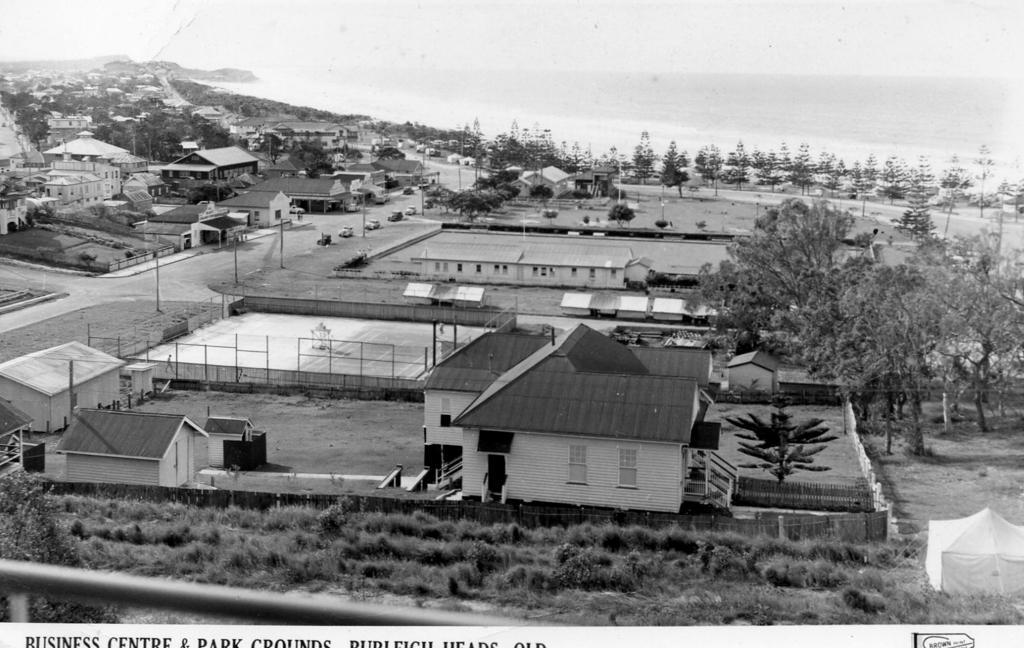Please provide a concise description of this image. This is a black and white image and here we can see buildings, sheds, trees, poles, tents, fences and some vehicles on the road. At the bottom, there is some text and a logo. 